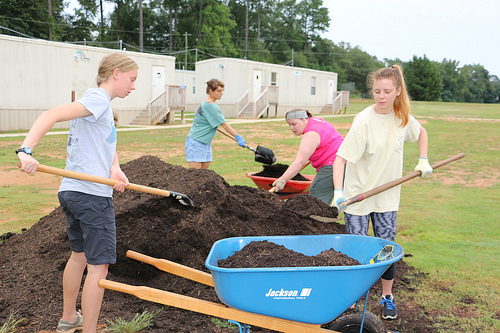<image>
Can you confirm if the dirt is on the ground? No. The dirt is not positioned on the ground. They may be near each other, but the dirt is not supported by or resting on top of the ground. Is the shovel in the soil? Yes. The shovel is contained within or inside the soil, showing a containment relationship. 